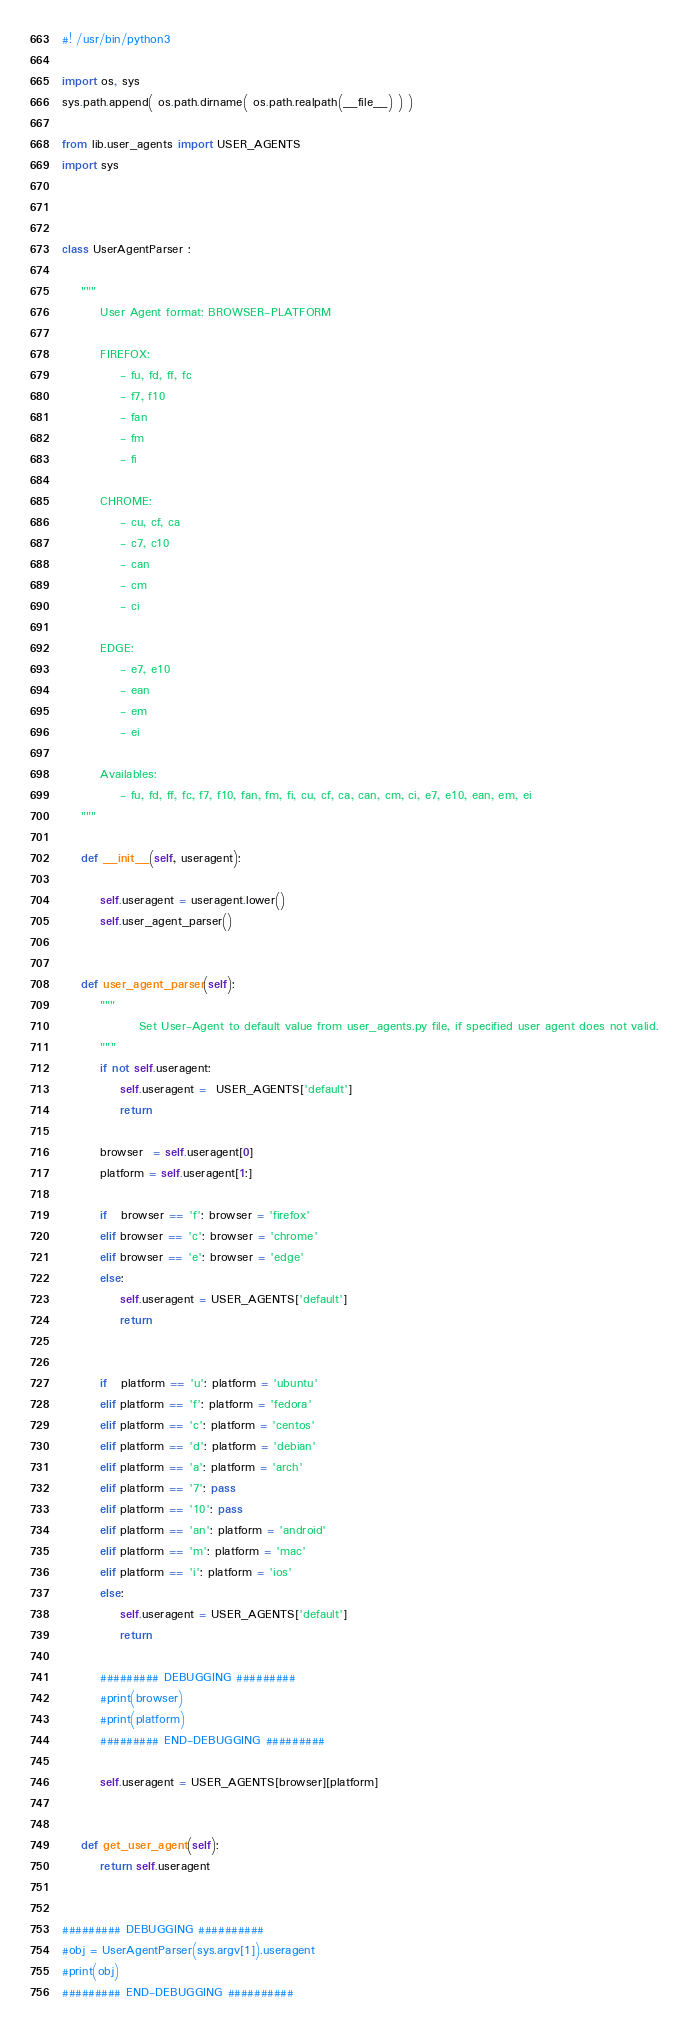<code> <loc_0><loc_0><loc_500><loc_500><_Python_>#! /usr/bin/python3 

import os, sys
sys.path.append( os.path.dirname( os.path.realpath(__file__) ) )

from lib.user_agents import USER_AGENTS
import sys



class UserAgentParser :

    """
        User Agent format: BROWSER-PLATFORM

        FIREFOX:
            - fu, fd, ff, fc
            - f7, f10
            - fan
            - fm
            - fi

        CHROME:
            - cu, cf, ca
            - c7, c10
            - can
            - cm
            - ci

        EDGE:
            - e7, e10
            - ean
            - em
            - ei
        
        Availables:
            - fu, fd, ff, fc, f7, f10, fan, fm, fi, cu, cf, ca, can, cm, ci, e7, e10, ean, em, ei
    """

    def __init__(self, useragent):
        
        self.useragent = useragent.lower()
        self.user_agent_parser()


    def user_agent_parser(self):
        """
                Set User-Agent to default value from user_agents.py file, if specified user agent does not valid.
        """
        if not self.useragent:
            self.useragent =  USER_AGENTS['default']
            return
        
        browser  = self.useragent[0]
        platform = self.useragent[1:]

        if   browser == 'f': browser = 'firefox'
        elif browser == 'c': browser = 'chrome'
        elif browser == 'e': browser = 'edge'
        else:
            self.useragent = USER_AGENTS['default']
            return


        if   platform == 'u': platform = 'ubuntu'
        elif platform == 'f': platform = 'fedora'
        elif platform == 'c': platform = 'centos'
        elif platform == 'd': platform = 'debian'
        elif platform == 'a': platform = 'arch'
        elif platform == '7': pass
        elif platform == '10': pass
        elif platform == 'an': platform = 'android'
        elif platform == 'm': platform = 'mac'
        elif platform == 'i': platform = 'ios'
        else: 
            self.useragent = USER_AGENTS['default']
            return
        
        ######### DEBUGGING #########
        #print(browser)
        #print(platform)
        ######### END-DEBUGGING #########

        self.useragent = USER_AGENTS[browser][platform]

    
    def get_user_agent(self):
        return self.useragent


######### DEBUGGING ##########
#obj = UserAgentParser(sys.argv[1]).useragent
#print(obj)
######### END-DEBUGGING ##########</code> 